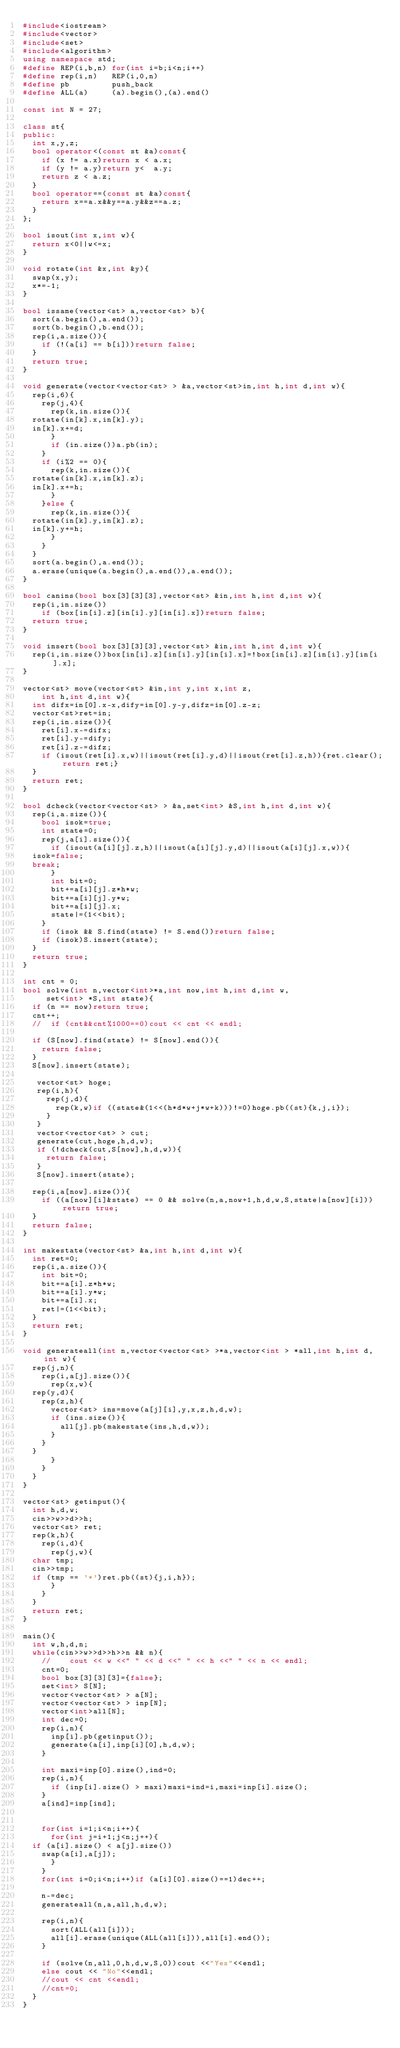Convert code to text. <code><loc_0><loc_0><loc_500><loc_500><_C++_>#include<iostream>
#include<vector>
#include<set>
#include<algorithm>
using namespace std;
#define REP(i,b,n) for(int i=b;i<n;i++)
#define rep(i,n)   REP(i,0,n)
#define pb         push_back
#define ALL(a)     (a).begin(),(a).end()

const int N = 27;

class st{
public:
  int x,y,z;
  bool operator<(const st &a)const{
    if (x != a.x)return x < a.x;
    if (y != a.y)return y<  a.y;
    return z < a.z;
  }
  bool operator==(const st &a)const{
    return x==a.x&&y==a.y&&z==a.z;
  }
};

bool isout(int x,int w){
  return x<0||w<=x;
}

void rotate(int &x,int &y){
  swap(x,y);
  x*=-1;
}

bool issame(vector<st> a,vector<st> b){
  sort(a.begin(),a.end());
  sort(b.begin(),b.end());
  rep(i,a.size()){
    if (!(a[i] == b[i]))return false;
  }
  return true;
}

void generate(vector<vector<st> > &a,vector<st>in,int h,int d,int w){
  rep(i,6){
    rep(j,4){
      rep(k,in.size()){
	rotate(in[k].x,in[k].y);
	in[k].x+=d;
      }
      if (in.size())a.pb(in);
    }
    if (i%2 == 0){
      rep(k,in.size()){
	rotate(in[k].x,in[k].z);
	in[k].x+=h;
      }
    }else {
      rep(k,in.size()){
	rotate(in[k].y,in[k].z);
	in[k].y+=h;
      }
    }
  }
  sort(a.begin(),a.end());
  a.erase(unique(a.begin(),a.end()),a.end());
}

bool canins(bool box[3][3][3],vector<st> &in,int h,int d,int w){
  rep(i,in.size())
    if (box[in[i].z][in[i].y][in[i].x])return false;
  return true;
}

void insert(bool box[3][3][3],vector<st> &in,int h,int d,int w){
  rep(i,in.size())box[in[i].z][in[i].y][in[i].x]=!box[in[i].z][in[i].y][in[i].x];
}

vector<st> move(vector<st> &in,int y,int x,int z,
		int h,int d,int w){
  int difx=in[0].x-x,dify=in[0].y-y,difz=in[0].z-z;
  vector<st>ret=in;
  rep(i,in.size()){
    ret[i].x-=difx;
    ret[i].y-=dify;
    ret[i].z-=difz;
    if (isout(ret[i].x,w)||isout(ret[i].y,d)||isout(ret[i].z,h)){ret.clear();return ret;}
  }
  return ret;
}

bool dcheck(vector<vector<st> > &a,set<int> &S,int h,int d,int w){
  rep(i,a.size()){
    bool isok=true;
    int state=0;
    rep(j,a[i].size()){
      if (isout(a[i][j].z,h)||isout(a[i][j].y,d)||isout(a[i][j].x,w)){
	isok=false;
	break;
      }
      int bit=0;
      bit+=a[i][j].z*h*w;
      bit+=a[i][j].y*w;
      bit+=a[i][j].x;
      state|=(1<<bit);
    }
    if (isok && S.find(state) != S.end())return false;
    if (isok)S.insert(state);
  }
  return true;
}

int cnt = 0;
bool solve(int n,vector<int>*a,int now,int h,int d,int w,
	   set<int> *S,int state){
  if (n == now)return true;
  cnt++;
  //  if (cnt&&cnt%1000==0)cout << cnt << endl;
  
  if (S[now].find(state) != S[now].end()){
    return false;
  }
  S[now].insert(state);

   vector<st> hoge;
   rep(i,h){
     rep(j,d){
       rep(k,w)if ((state&(1<<(h*d*w+j*w+k)))!=0)hoge.pb((st){k,j,i});
     }
   }
   vector<vector<st> > cut;
   generate(cut,hoge,h,d,w);
   if (!dcheck(cut,S[now],h,d,w)){
     return false;
   }
   S[now].insert(state);

  rep(i,a[now].size()){
    if ((a[now][i]&state) == 0 && solve(n,a,now+1,h,d,w,S,state|a[now][i]))return true;
  }
  return false;
}

int makestate(vector<st> &a,int h,int d,int w){
  int ret=0;
  rep(i,a.size()){
    int bit=0;
    bit+=a[i].z*h*w;
    bit+=a[i].y*w;
    bit+=a[i].x;
    ret|=(1<<bit);
  }
  return ret;
}

void generateall(int n,vector<vector<st> >*a,vector<int > *all,int h,int d,int w){
  rep(j,n){
    rep(i,a[j].size()){
      rep(x,w){
	rep(y,d){
	  rep(z,h){
	    vector<st> ins=move(a[j][i],y,x,z,h,d,w);
	    if (ins.size()){
	      all[j].pb(makestate(ins,h,d,w));
	    }
	  }
	}
      }
    }
  }
}

vector<st> getinput(){
  int h,d,w;
  cin>>w>>d>>h;
  vector<st> ret;
  rep(k,h){
    rep(i,d){
      rep(j,w){
	char tmp;
	cin>>tmp;
	if (tmp == '*')ret.pb((st){j,i,h});
      }
    }
  }
  return ret;
}

main(){
  int w,h,d,n;
  while(cin>>w>>d>>h>>n && n){
    //    cout << w <<" " << d <<" " << h <<" " << n << endl;
    cnt=0;
    bool box[3][3][3]={false};
    set<int> S[N];
    vector<vector<st> > a[N];
    vector<vector<st> > inp[N];
    vector<int>all[N];
    int dec=0;
    rep(i,n){
      inp[i].pb(getinput());
      generate(a[i],inp[i][0],h,d,w);
    }

    int maxi=inp[0].size(),ind=0;
    rep(i,n){
      if (inp[i].size() > maxi)maxi=ind=i,maxi=inp[i].size();
    }
    a[ind]=inp[ind];


    for(int i=1;i<n;i++){
      for(int j=i+1;j<n;j++){
	if (a[i].size() < a[j].size())
	  swap(a[i],a[j]);
      }
    }
    for(int i=0;i<n;i++)if (a[i][0].size()==1)dec++;
    
    n-=dec;
    generateall(n,a,all,h,d,w);
    
    rep(i,n){
      sort(ALL(all[i]));
      all[i].erase(unique(ALL(all[i])),all[i].end());
    }

    if (solve(n,all,0,h,d,w,S,0))cout <<"Yes"<<endl;
    else cout << "No"<<endl;
    //cout << cnt <<endl;
    //cnt=0;
  }
}</code> 